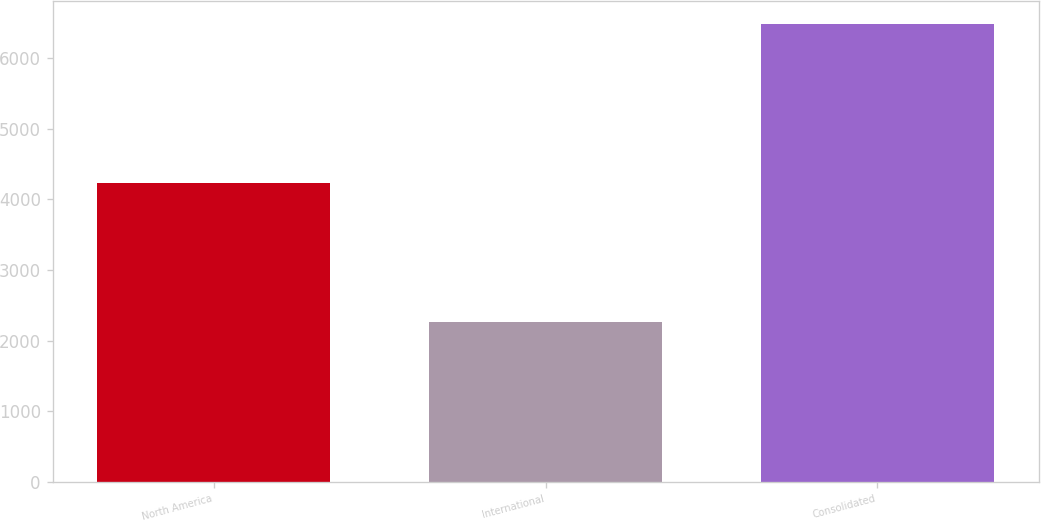<chart> <loc_0><loc_0><loc_500><loc_500><bar_chart><fcel>North America<fcel>International<fcel>Consolidated<nl><fcel>4227<fcel>2258<fcel>6485<nl></chart> 